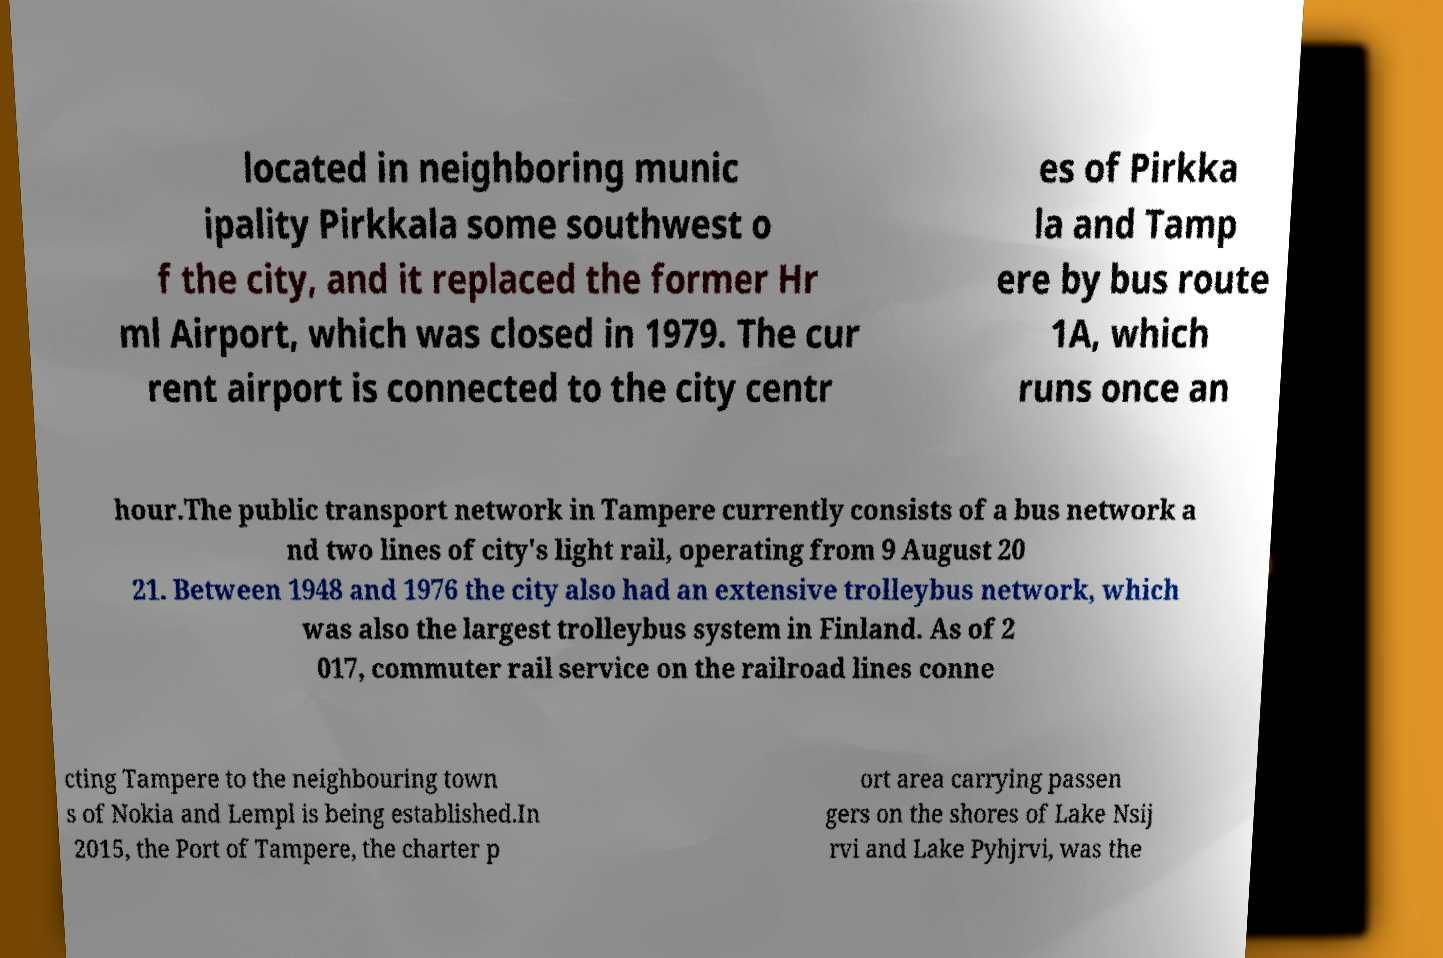Can you read and provide the text displayed in the image?This photo seems to have some interesting text. Can you extract and type it out for me? located in neighboring munic ipality Pirkkala some southwest o f the city, and it replaced the former Hr ml Airport, which was closed in 1979. The cur rent airport is connected to the city centr es of Pirkka la and Tamp ere by bus route 1A, which runs once an hour.The public transport network in Tampere currently consists of a bus network a nd two lines of city's light rail, operating from 9 August 20 21. Between 1948 and 1976 the city also had an extensive trolleybus network, which was also the largest trolleybus system in Finland. As of 2 017, commuter rail service on the railroad lines conne cting Tampere to the neighbouring town s of Nokia and Lempl is being established.In 2015, the Port of Tampere, the charter p ort area carrying passen gers on the shores of Lake Nsij rvi and Lake Pyhjrvi, was the 